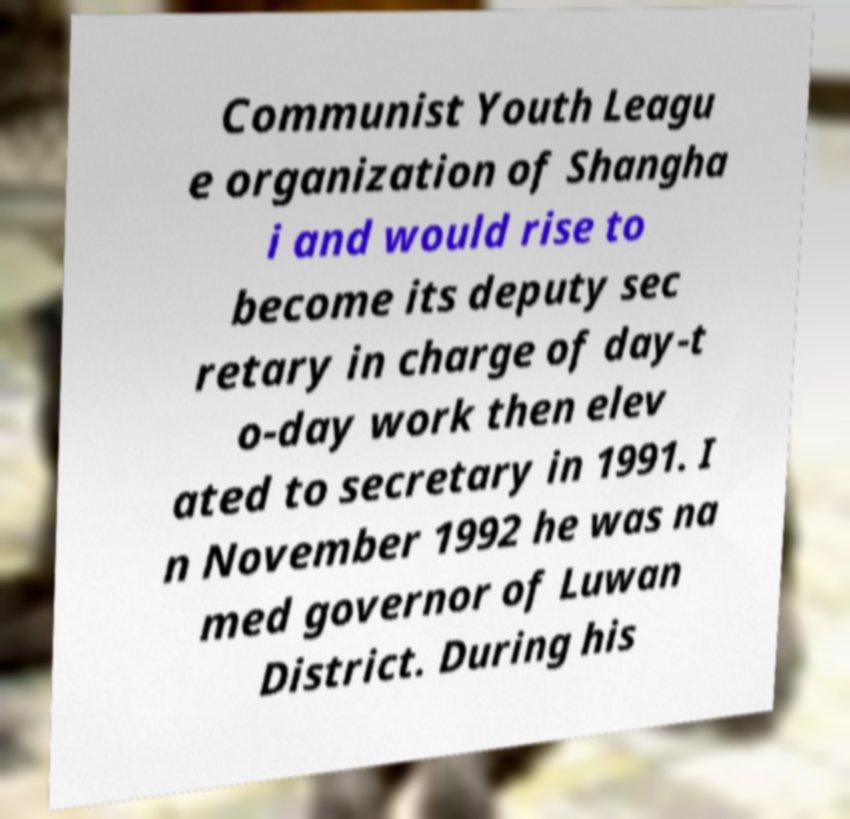Please read and relay the text visible in this image. What does it say? Communist Youth Leagu e organization of Shangha i and would rise to become its deputy sec retary in charge of day-t o-day work then elev ated to secretary in 1991. I n November 1992 he was na med governor of Luwan District. During his 